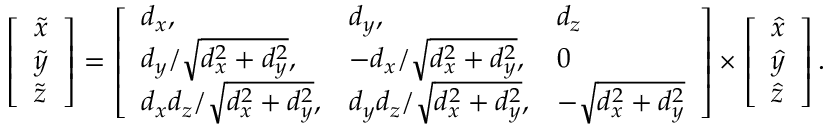Convert formula to latex. <formula><loc_0><loc_0><loc_500><loc_500>\begin{array} { r } { \left [ \begin{array} { l } { \tilde { x } } \\ { \tilde { y } } \\ { \tilde { z } } \end{array} \right ] = \left [ \begin{array} { l l l } { d _ { x } , } & { d _ { y } , } & { d _ { z } } \\ { { d _ { y } } / { \sqrt { d _ { x } ^ { 2 } + d _ { y } ^ { 2 } } } , } & { { - d _ { x } } / { \sqrt { d _ { x } ^ { 2 } + d _ { y } ^ { 2 } } } , } & { 0 } \\ { { d _ { x } d _ { z } } / { \sqrt { d _ { x } ^ { 2 } + d _ { y } ^ { 2 } } } , } & { { d _ { y } d _ { z } } / { \sqrt { d _ { x } ^ { 2 } + d _ { y } ^ { 2 } } } , } & { - \sqrt { d _ { x } ^ { 2 } + d _ { y } ^ { 2 } } } \end{array} \right ] \times \left [ \begin{array} { l } { \hat { x } } \\ { \hat { y } } \\ { \hat { z } } \end{array} \right ] . } \end{array}</formula> 